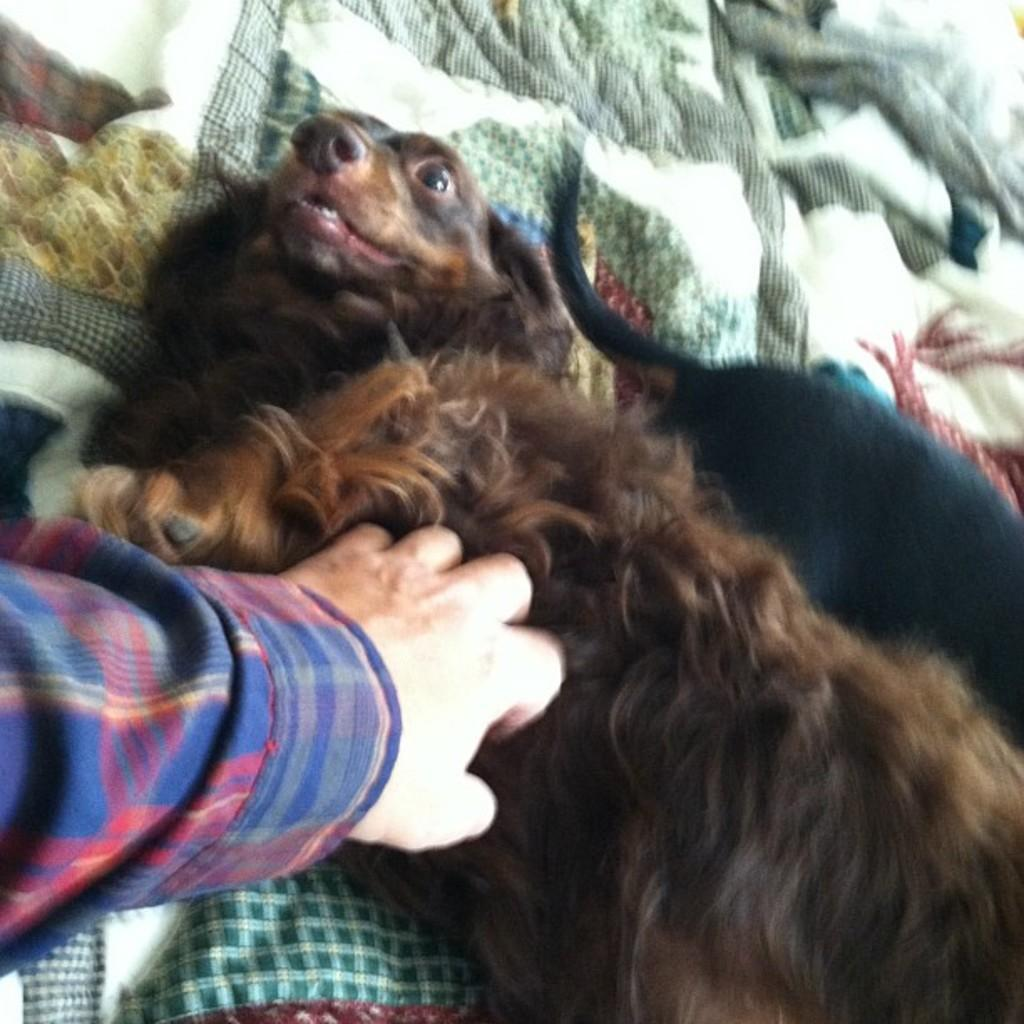What animals are present in the image? There are dogs in the image. What are the dogs lying on? The dogs are lying on a blanket. Can you describe any interaction between the dogs and a person in the image? There is a person's hand on a dog in the image. How many brothers can be seen playing with the dogs in the image? There are no brothers present in the image, and the dogs are lying on a blanket rather than playing. 